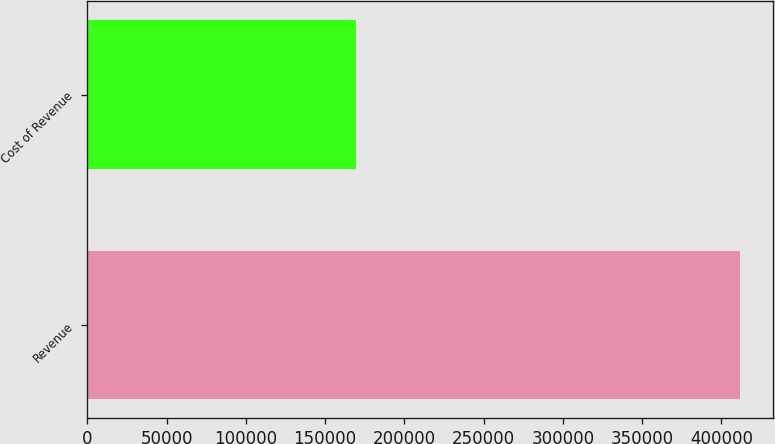Convert chart to OTSL. <chart><loc_0><loc_0><loc_500><loc_500><bar_chart><fcel>Revenue<fcel>Cost of Revenue<nl><fcel>412021<fcel>169793<nl></chart> 